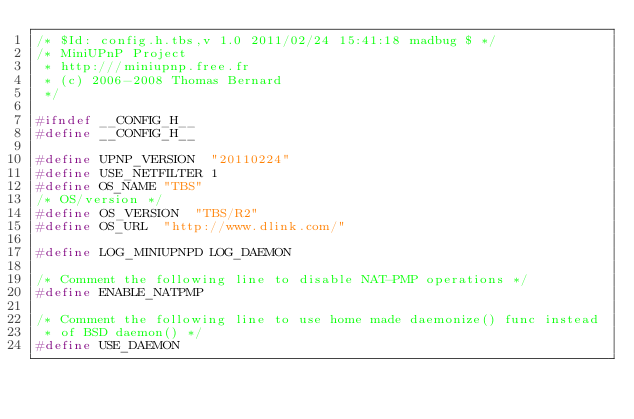<code> <loc_0><loc_0><loc_500><loc_500><_C_>/* $Id: config.h.tbs,v 1.0 2011/02/24 15:41:18 madbug $ */
/* MiniUPnP Project
 * http:///miniupnp.free.fr
 * (c) 2006-2008 Thomas Bernard
 */

#ifndef __CONFIG_H__
#define __CONFIG_H__

#define UPNP_VERSION	"20110224"
#define USE_NETFILTER 1
#define OS_NAME	"TBS"
/* OS/version */
#define OS_VERSION	"TBS/R2"
#define OS_URL	"http://www.dlink.com/"

#define LOG_MINIUPNPD	LOG_DAEMON

/* Comment the following line to disable NAT-PMP operations */
#define ENABLE_NATPMP

/* Comment the following line to use home made daemonize() func instead
 * of BSD daemon() */
#define USE_DAEMON
</code> 